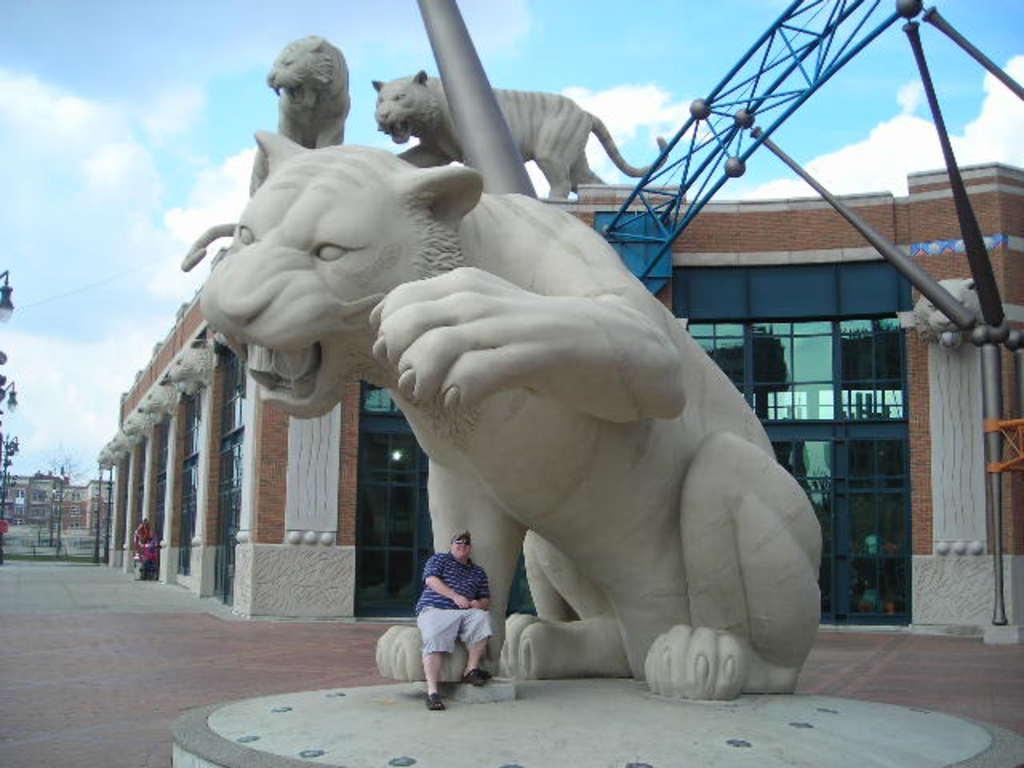How would you summarize this image in a sentence or two? In this image we can see three animal sculptures, there are some buildings, poles, and light poles, there are two persons, one of them is sitting on a sculpture, also we can see the sky. 